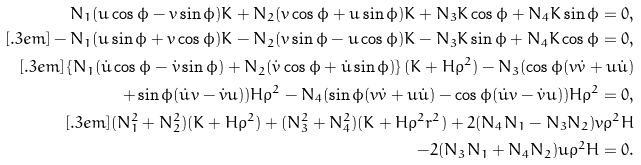Convert formula to latex. <formula><loc_0><loc_0><loc_500><loc_500>N _ { 1 } ( u \cos \phi - v \sin \phi ) K + N _ { 2 } ( v \cos \phi + u \sin \phi ) K + N _ { 3 } K \cos \phi + N _ { 4 } K \sin \phi = 0 , \\ [ . 3 e m ] - N _ { 1 } ( u \sin \phi + v \cos \phi ) K - N _ { 2 } ( v \sin \phi - u \cos \phi ) K - N _ { 3 } K \sin \phi + N _ { 4 } K \cos \phi = 0 , \\ [ . 3 e m ] \left \{ N _ { 1 } ( \dot { u } \cos \phi - \dot { v } \sin \phi ) + N _ { 2 } ( \dot { v } \cos \phi + \dot { u } \sin \phi ) \right \} ( K + H \rho ^ { 2 } ) - N _ { 3 } ( \cos \phi ( v \dot { v } + u \dot { u } ) \\ + \sin \phi ( \dot { u } v - \dot { v } u ) ) H \rho ^ { 2 } - N _ { 4 } ( \sin \phi ( v \dot { v } + u \dot { u } ) - \cos \phi ( \dot { u } v - \dot { v } u ) ) H \rho ^ { 2 } = 0 , \\ [ . 3 e m ] ( N _ { 1 } ^ { 2 } + N _ { 2 } ^ { 2 } ) ( K + H \rho ^ { 2 } ) + ( N _ { 3 } ^ { 2 } + N _ { 4 } ^ { 2 } ) ( K + H \rho ^ { 2 } r ^ { 2 } ) + 2 ( N _ { 4 } N _ { 1 } - N _ { 3 } N _ { 2 } ) v \rho ^ { 2 } H \\ - 2 ( N _ { 3 } N _ { 1 } + N _ { 4 } N _ { 2 } ) u \rho ^ { 2 } H = 0 .</formula> 